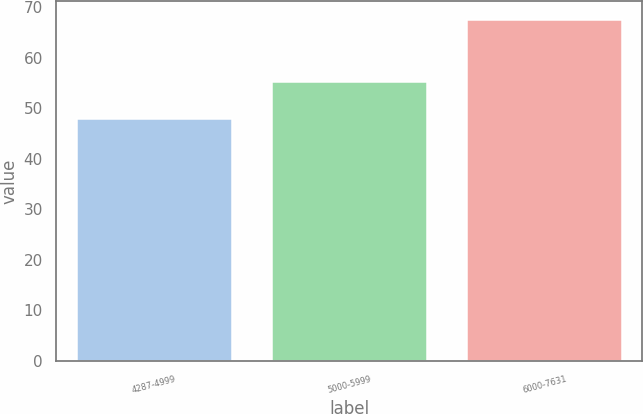Convert chart to OTSL. <chart><loc_0><loc_0><loc_500><loc_500><bar_chart><fcel>4287-4999<fcel>5000-5999<fcel>6000-7631<nl><fcel>48.07<fcel>55.42<fcel>67.79<nl></chart> 